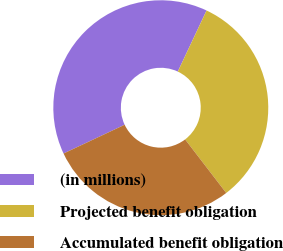Convert chart. <chart><loc_0><loc_0><loc_500><loc_500><pie_chart><fcel>(in millions)<fcel>Projected benefit obligation<fcel>Accumulated benefit obligation<nl><fcel>39.01%<fcel>32.58%<fcel>28.42%<nl></chart> 